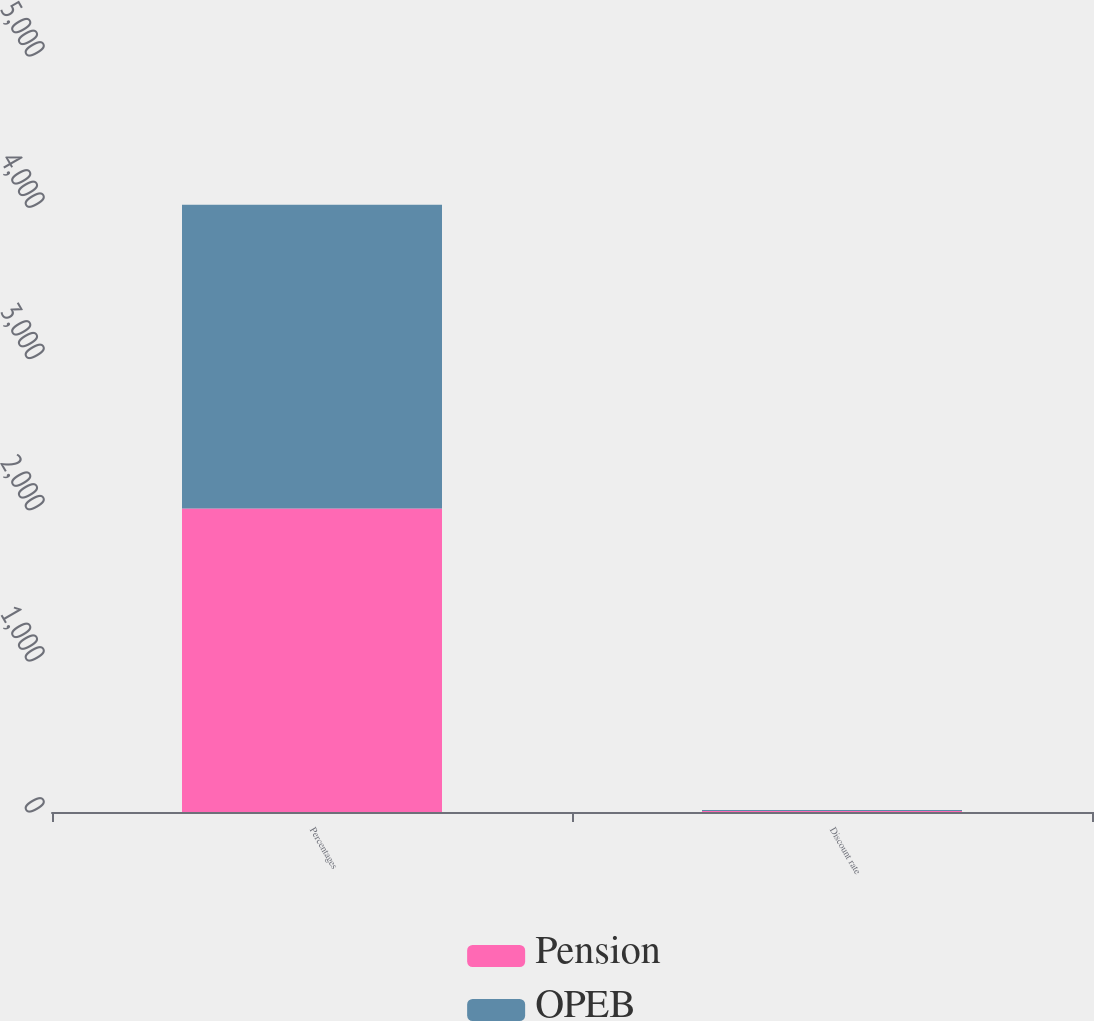Convert chart to OTSL. <chart><loc_0><loc_0><loc_500><loc_500><stacked_bar_chart><ecel><fcel>Percentages<fcel>Discount rate<nl><fcel>Pension<fcel>2008<fcel>6.25<nl><fcel>OPEB<fcel>2008<fcel>6.25<nl></chart> 